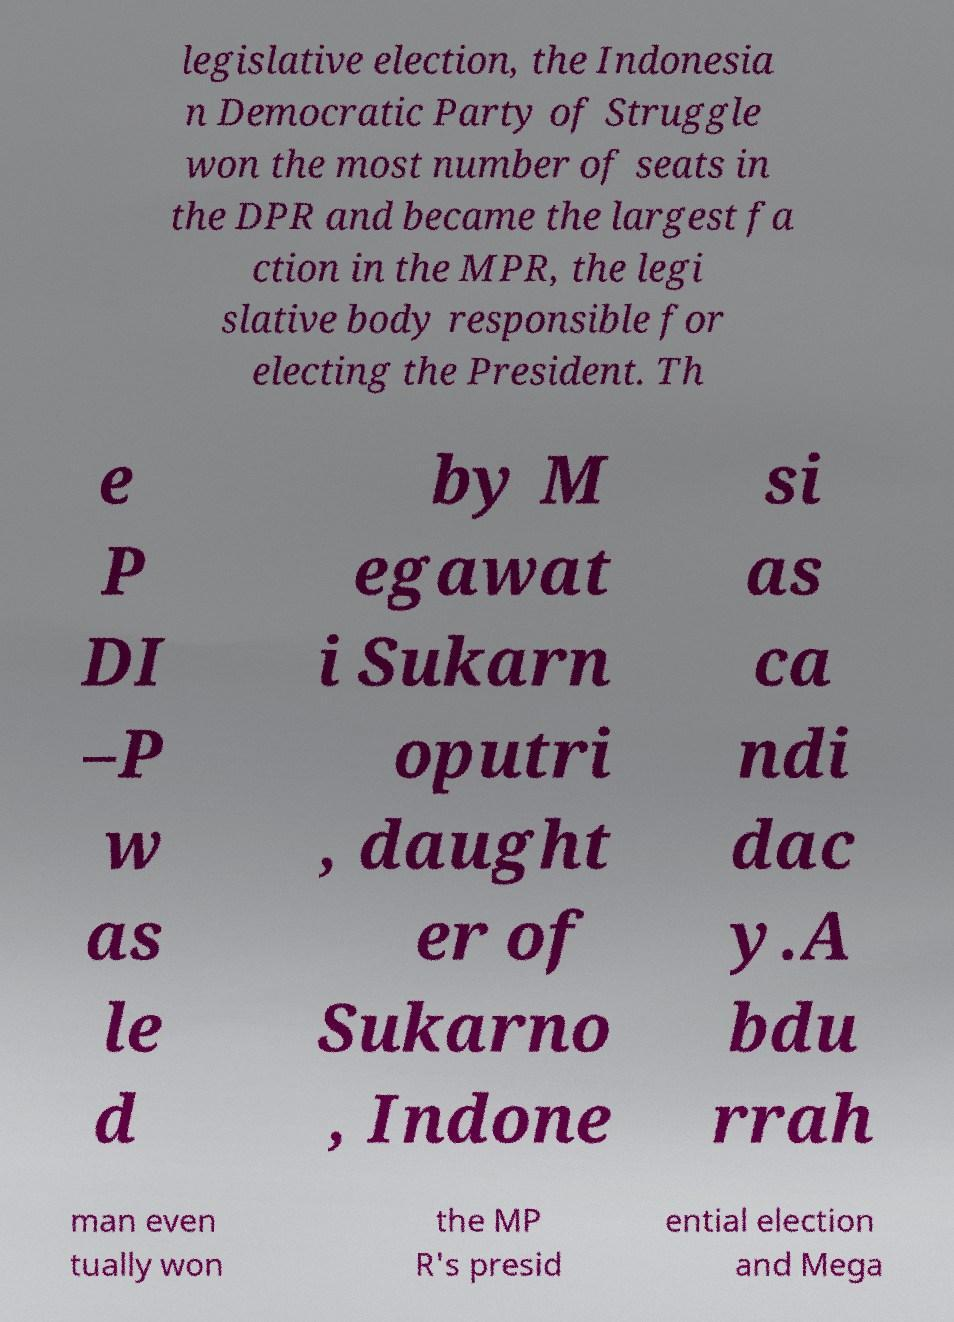Could you extract and type out the text from this image? legislative election, the Indonesia n Democratic Party of Struggle won the most number of seats in the DPR and became the largest fa ction in the MPR, the legi slative body responsible for electing the President. Th e P DI –P w as le d by M egawat i Sukarn oputri , daught er of Sukarno , Indone si as ca ndi dac y.A bdu rrah man even tually won the MP R's presid ential election and Mega 